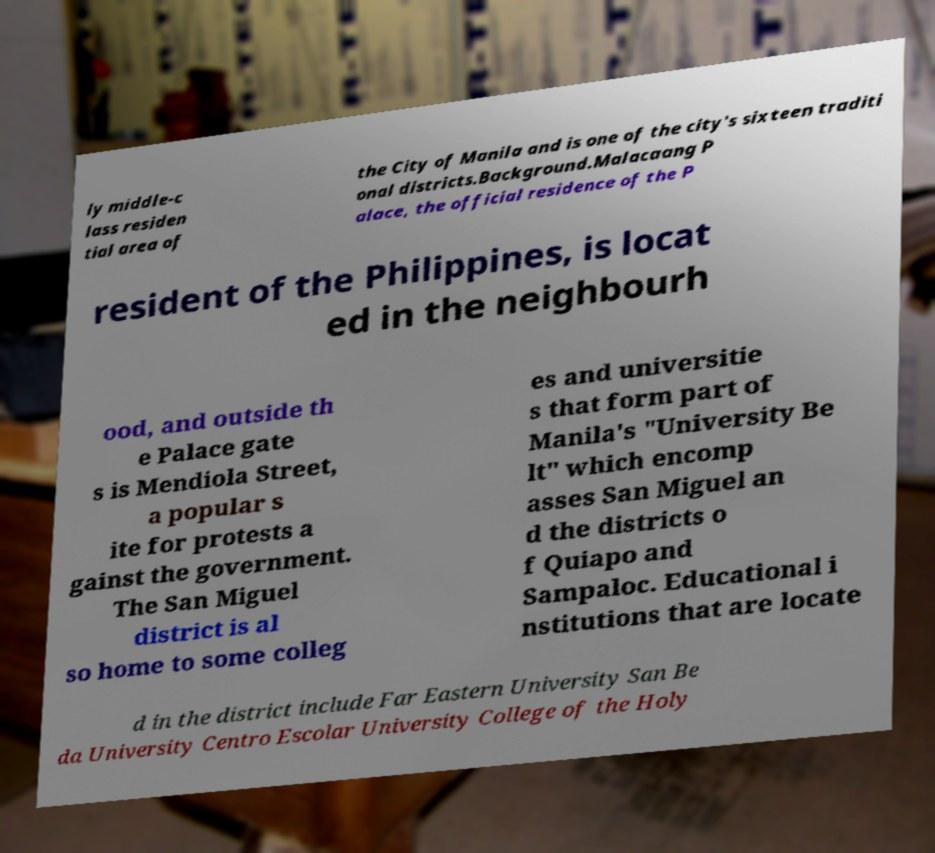Please identify and transcribe the text found in this image. ly middle-c lass residen tial area of the City of Manila and is one of the city's sixteen traditi onal districts.Background.Malacaang P alace, the official residence of the P resident of the Philippines, is locat ed in the neighbourh ood, and outside th e Palace gate s is Mendiola Street, a popular s ite for protests a gainst the government. The San Miguel district is al so home to some colleg es and universitie s that form part of Manila's "University Be lt" which encomp asses San Miguel an d the districts o f Quiapo and Sampaloc. Educational i nstitutions that are locate d in the district include Far Eastern University San Be da University Centro Escolar University College of the Holy 